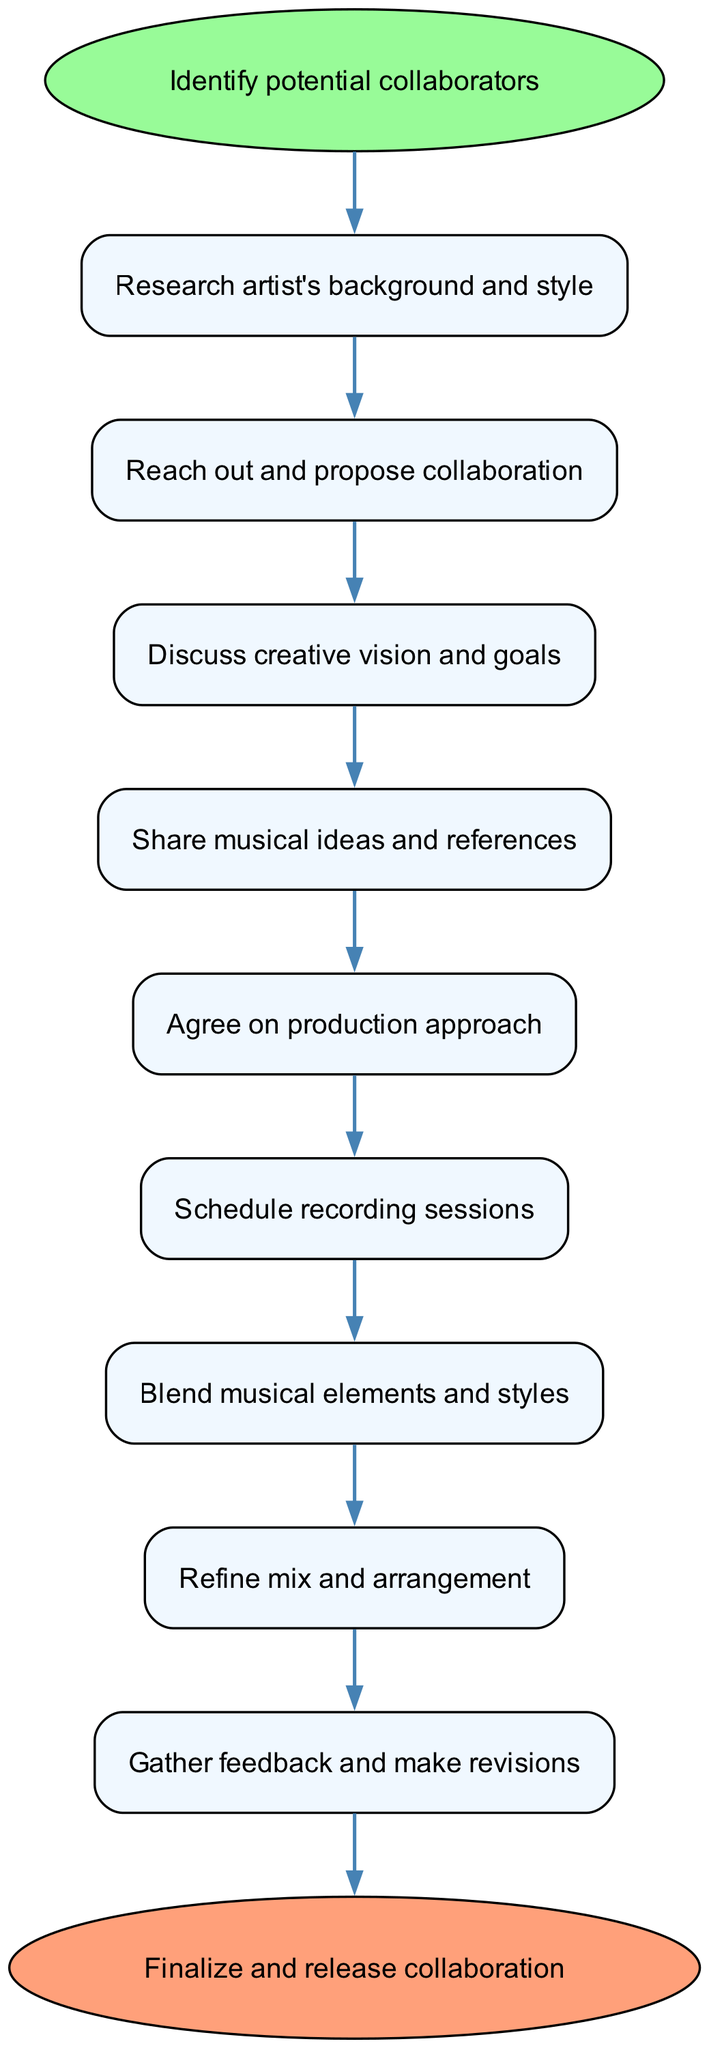What is the first step in the collaboration process? The first step in the collaboration process, as indicated in the diagram, is represented by the node labeled "Identify potential collaborators."
Answer: Identify potential collaborators How many nodes are present in the diagram? The diagram contains a total of 11 nodes, including the start and end nodes.
Answer: 11 Which node follows "Share musical ideas and references"? The node that follows "Share musical ideas and references" is "Agree on production approach." This can be identified by tracing the flow from node 4 to node 5 in the diagram.
Answer: Agree on production approach What is the last step before finalizing the collaboration? The last step before finalizing the collaboration is "Gather feedback and make revisions," which is the node just before the end node in the flow.
Answer: Gather feedback and make revisions What step comes after agreeing on the production approach? After agreeing on the production approach, the next step is to "Schedule recording sessions." This can be confirmed by examining the connection from node 5 to node 6 in the diagram.
Answer: Schedule recording sessions How many connections are there in the diagram? The diagram includes 10 connections, which represent the flow from one step to the next. Counting the arrows between the nodes confirms this.
Answer: 10 What step occurs immediately after discussing creative vision and goals? The step that occurs immediately after discussing creative vision and goals is "Share musical ideas and references," which is the direct successor node to the discussion step.
Answer: Share musical ideas and references Which node is represented by an ellipse shape in the diagram? The nodes that are represented by an ellipse shape are "Identify potential collaborators" and "Finalize and release collaboration," indicating they are the start and end points of the flowchart respectively.
Answer: Identify potential collaborators; Finalize and release collaboration 